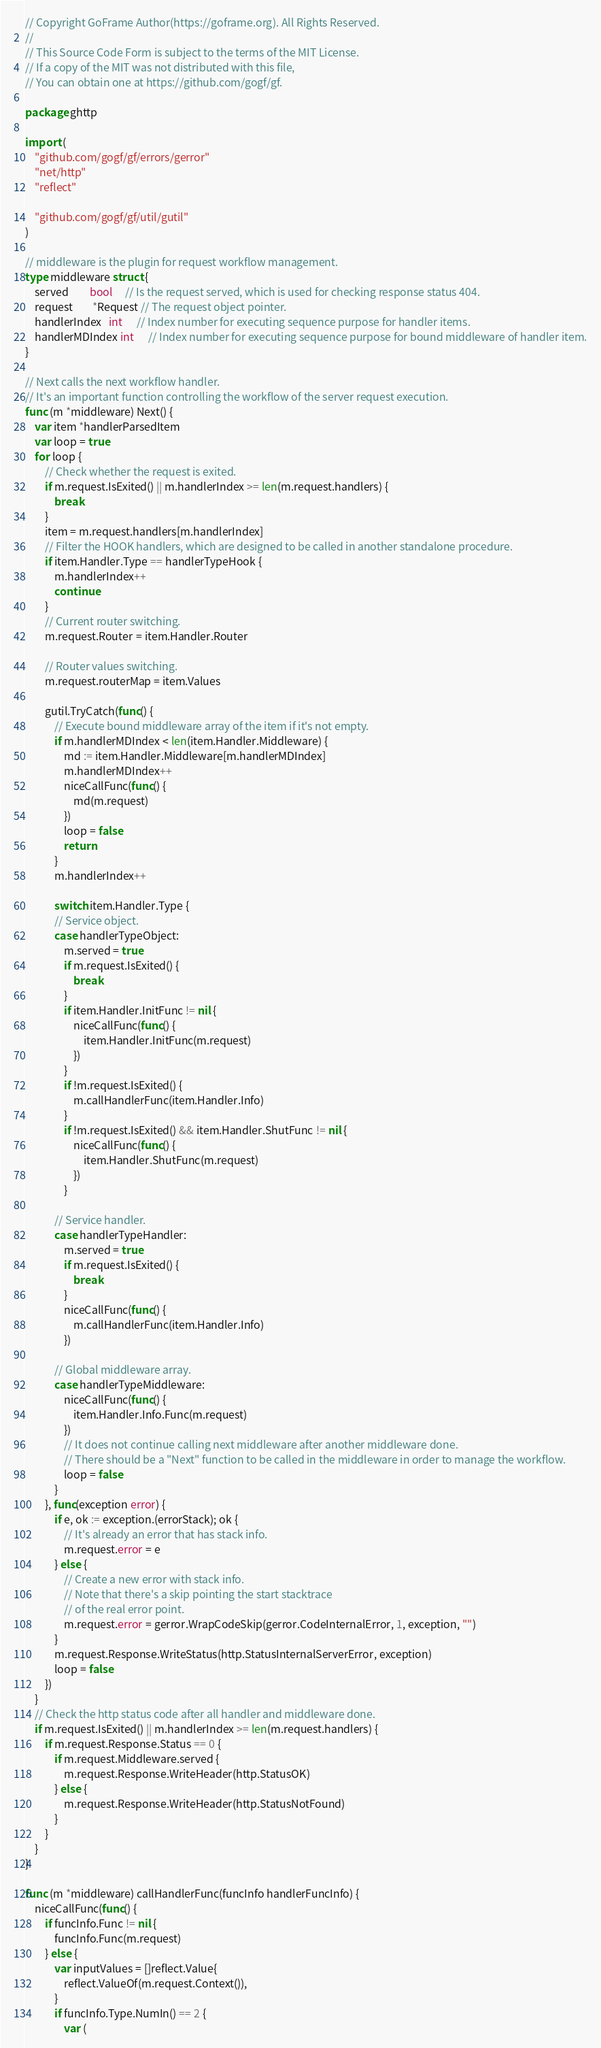Convert code to text. <code><loc_0><loc_0><loc_500><loc_500><_Go_>// Copyright GoFrame Author(https://goframe.org). All Rights Reserved.
//
// This Source Code Form is subject to the terms of the MIT License.
// If a copy of the MIT was not distributed with this file,
// You can obtain one at https://github.com/gogf/gf.

package ghttp

import (
	"github.com/gogf/gf/errors/gerror"
	"net/http"
	"reflect"

	"github.com/gogf/gf/util/gutil"
)

// middleware is the plugin for request workflow management.
type middleware struct {
	served         bool     // Is the request served, which is used for checking response status 404.
	request        *Request // The request object pointer.
	handlerIndex   int      // Index number for executing sequence purpose for handler items.
	handlerMDIndex int      // Index number for executing sequence purpose for bound middleware of handler item.
}

// Next calls the next workflow handler.
// It's an important function controlling the workflow of the server request execution.
func (m *middleware) Next() {
	var item *handlerParsedItem
	var loop = true
	for loop {
		// Check whether the request is exited.
		if m.request.IsExited() || m.handlerIndex >= len(m.request.handlers) {
			break
		}
		item = m.request.handlers[m.handlerIndex]
		// Filter the HOOK handlers, which are designed to be called in another standalone procedure.
		if item.Handler.Type == handlerTypeHook {
			m.handlerIndex++
			continue
		}
		// Current router switching.
		m.request.Router = item.Handler.Router

		// Router values switching.
		m.request.routerMap = item.Values

		gutil.TryCatch(func() {
			// Execute bound middleware array of the item if it's not empty.
			if m.handlerMDIndex < len(item.Handler.Middleware) {
				md := item.Handler.Middleware[m.handlerMDIndex]
				m.handlerMDIndex++
				niceCallFunc(func() {
					md(m.request)
				})
				loop = false
				return
			}
			m.handlerIndex++

			switch item.Handler.Type {
			// Service object.
			case handlerTypeObject:
				m.served = true
				if m.request.IsExited() {
					break
				}
				if item.Handler.InitFunc != nil {
					niceCallFunc(func() {
						item.Handler.InitFunc(m.request)
					})
				}
				if !m.request.IsExited() {
					m.callHandlerFunc(item.Handler.Info)
				}
				if !m.request.IsExited() && item.Handler.ShutFunc != nil {
					niceCallFunc(func() {
						item.Handler.ShutFunc(m.request)
					})
				}

			// Service handler.
			case handlerTypeHandler:
				m.served = true
				if m.request.IsExited() {
					break
				}
				niceCallFunc(func() {
					m.callHandlerFunc(item.Handler.Info)
				})

			// Global middleware array.
			case handlerTypeMiddleware:
				niceCallFunc(func() {
					item.Handler.Info.Func(m.request)
				})
				// It does not continue calling next middleware after another middleware done.
				// There should be a "Next" function to be called in the middleware in order to manage the workflow.
				loop = false
			}
		}, func(exception error) {
			if e, ok := exception.(errorStack); ok {
				// It's already an error that has stack info.
				m.request.error = e
			} else {
				// Create a new error with stack info.
				// Note that there's a skip pointing the start stacktrace
				// of the real error point.
				m.request.error = gerror.WrapCodeSkip(gerror.CodeInternalError, 1, exception, "")
			}
			m.request.Response.WriteStatus(http.StatusInternalServerError, exception)
			loop = false
		})
	}
	// Check the http status code after all handler and middleware done.
	if m.request.IsExited() || m.handlerIndex >= len(m.request.handlers) {
		if m.request.Response.Status == 0 {
			if m.request.Middleware.served {
				m.request.Response.WriteHeader(http.StatusOK)
			} else {
				m.request.Response.WriteHeader(http.StatusNotFound)
			}
		}
	}
}

func (m *middleware) callHandlerFunc(funcInfo handlerFuncInfo) {
	niceCallFunc(func() {
		if funcInfo.Func != nil {
			funcInfo.Func(m.request)
		} else {
			var inputValues = []reflect.Value{
				reflect.ValueOf(m.request.Context()),
			}
			if funcInfo.Type.NumIn() == 2 {
				var (</code> 